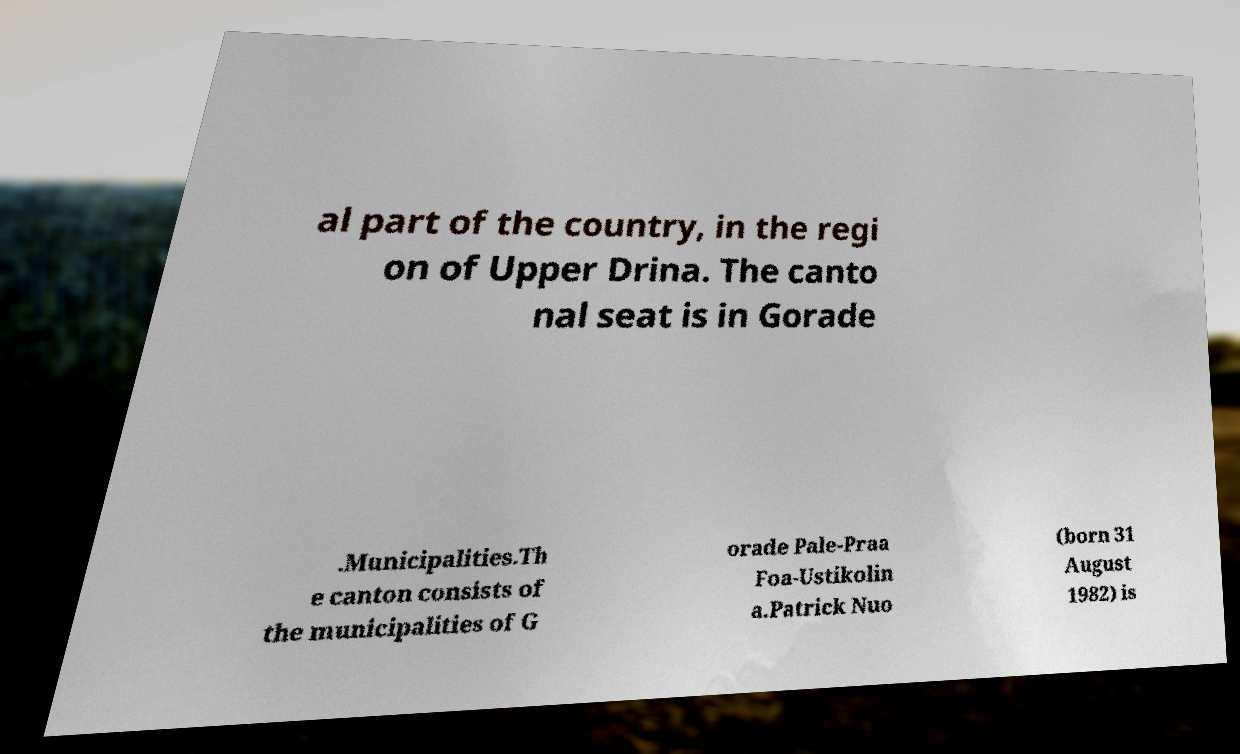Could you assist in decoding the text presented in this image and type it out clearly? al part of the country, in the regi on of Upper Drina. The canto nal seat is in Gorade .Municipalities.Th e canton consists of the municipalities of G orade Pale-Praa Foa-Ustikolin a.Patrick Nuo (born 31 August 1982) is 